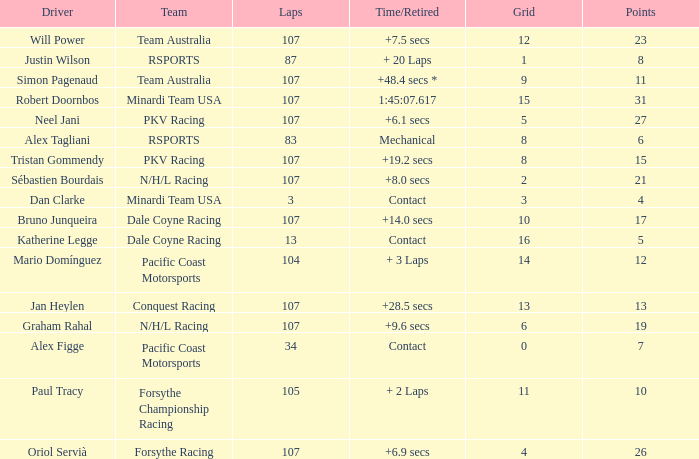What is the highest number of points scored by minardi team usa in more than 13 laps? 31.0. 